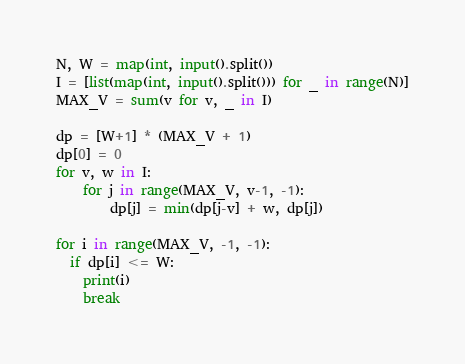Convert code to text. <code><loc_0><loc_0><loc_500><loc_500><_Python_>N, W = map(int, input().split())
I = [list(map(int, input().split())) for _ in range(N)]
MAX_V = sum(v for v, _ in I)

dp = [W+1] * (MAX_V + 1)
dp[0] = 0
for v, w in I:
    for j in range(MAX_V, v-1, -1):
        dp[j] = min(dp[j-v] + w, dp[j])
        
for i in range(MAX_V, -1, -1):
  if dp[i] <= W:
    print(i)
    break

</code> 